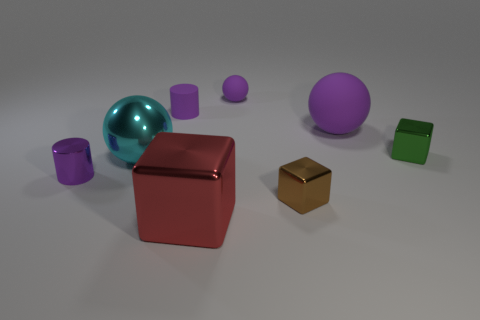How many objects are in this scene, and can you categorize them by shape? In the scene, there are a total of seven objects. They can be categorized by shape as follows: three cubes—two are similar in size and purple, and one is smaller and green; one cuboid that is golden in color; and three spheres—two larger ones, one teal and one purple, and a small purple one that matches the larger sphere in color.  What can you tell me about the lighting and shadows in this image? The lighting in the image appears to be diffuse, coming from above, casting soft shadows to the right side of the objects. This even lighting suggests a controlled environment, potentially set up for the purpose of 3D rendering or product display. 